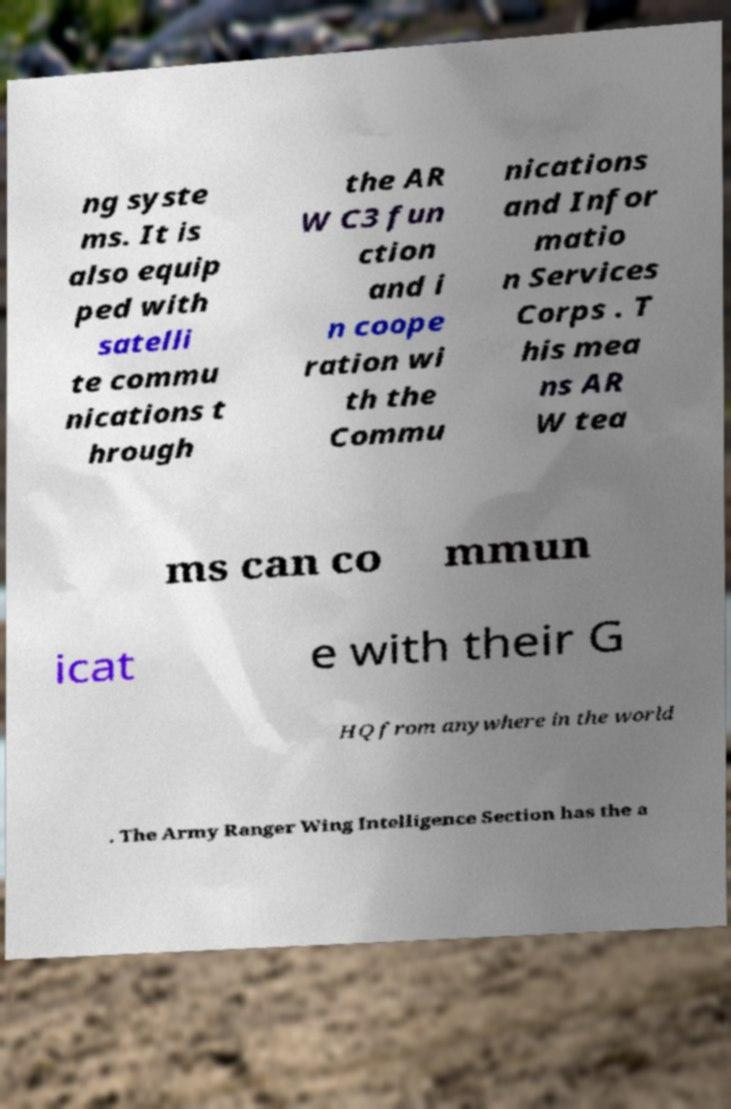Please read and relay the text visible in this image. What does it say? ng syste ms. It is also equip ped with satelli te commu nications t hrough the AR W C3 fun ction and i n coope ration wi th the Commu nications and Infor matio n Services Corps . T his mea ns AR W tea ms can co mmun icat e with their G HQ from anywhere in the world . The Army Ranger Wing Intelligence Section has the a 